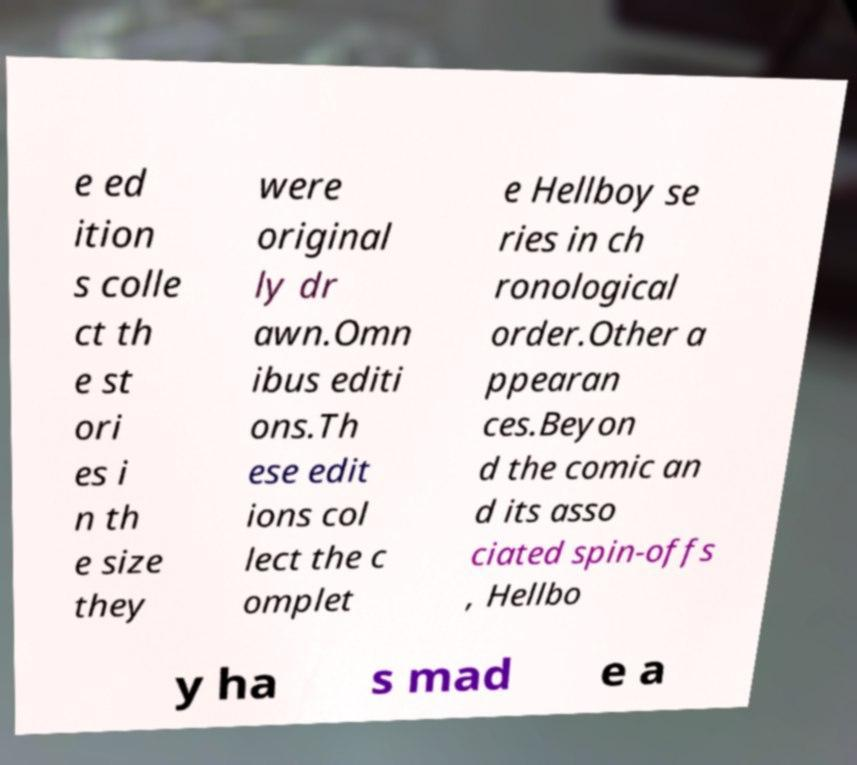For documentation purposes, I need the text within this image transcribed. Could you provide that? e ed ition s colle ct th e st ori es i n th e size they were original ly dr awn.Omn ibus editi ons.Th ese edit ions col lect the c omplet e Hellboy se ries in ch ronological order.Other a ppearan ces.Beyon d the comic an d its asso ciated spin-offs , Hellbo y ha s mad e a 